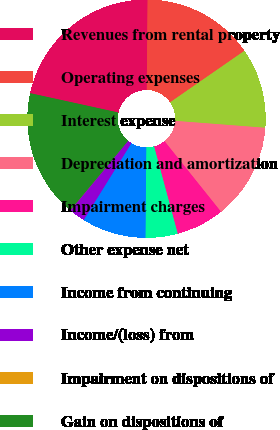Convert chart. <chart><loc_0><loc_0><loc_500><loc_500><pie_chart><fcel>Revenues from rental property<fcel>Operating expenses<fcel>Interest expense<fcel>Depreciation and amortization<fcel>Impairment charges<fcel>Other expense net<fcel>Income from continuing<fcel>Income/(loss) from<fcel>Impairment on dispositions of<fcel>Gain on dispositions of<nl><fcel>21.72%<fcel>15.21%<fcel>10.87%<fcel>13.04%<fcel>6.53%<fcel>4.36%<fcel>8.7%<fcel>2.19%<fcel>0.02%<fcel>17.38%<nl></chart> 